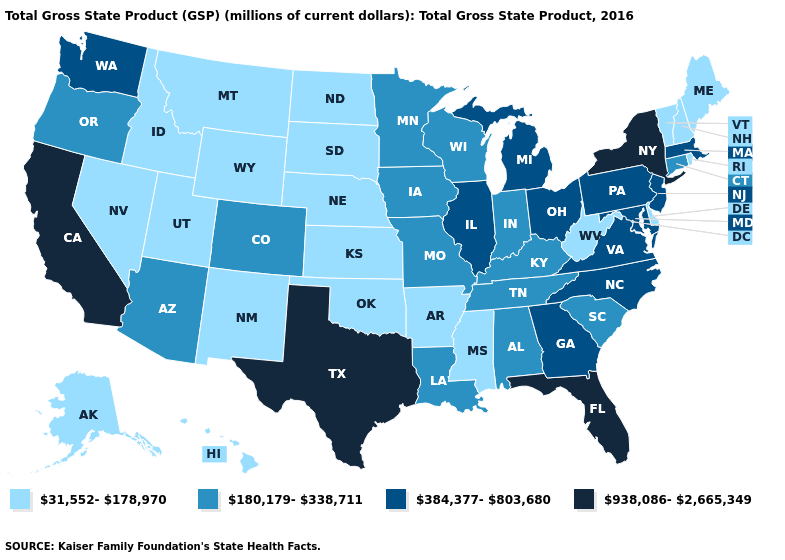What is the value of South Carolina?
Answer briefly. 180,179-338,711. What is the value of Nebraska?
Give a very brief answer. 31,552-178,970. Does the map have missing data?
Write a very short answer. No. Name the states that have a value in the range 938,086-2,665,349?
Keep it brief. California, Florida, New York, Texas. What is the lowest value in states that border Indiana?
Short answer required. 180,179-338,711. Which states have the lowest value in the USA?
Give a very brief answer. Alaska, Arkansas, Delaware, Hawaii, Idaho, Kansas, Maine, Mississippi, Montana, Nebraska, Nevada, New Hampshire, New Mexico, North Dakota, Oklahoma, Rhode Island, South Dakota, Utah, Vermont, West Virginia, Wyoming. Does Mississippi have the lowest value in the South?
Concise answer only. Yes. Which states hav the highest value in the West?
Give a very brief answer. California. What is the value of Utah?
Give a very brief answer. 31,552-178,970. Which states have the highest value in the USA?
Write a very short answer. California, Florida, New York, Texas. Does Alabama have a lower value than Florida?
Concise answer only. Yes. What is the value of Wisconsin?
Answer briefly. 180,179-338,711. Among the states that border Montana , which have the highest value?
Concise answer only. Idaho, North Dakota, South Dakota, Wyoming. What is the lowest value in states that border South Dakota?
Keep it brief. 31,552-178,970. Name the states that have a value in the range 31,552-178,970?
Be succinct. Alaska, Arkansas, Delaware, Hawaii, Idaho, Kansas, Maine, Mississippi, Montana, Nebraska, Nevada, New Hampshire, New Mexico, North Dakota, Oklahoma, Rhode Island, South Dakota, Utah, Vermont, West Virginia, Wyoming. 